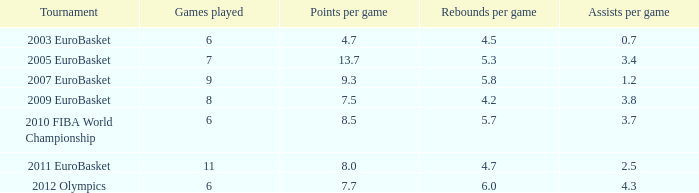How many assists per contest were there in the 2010 fiba world championship? 3.7. Would you be able to parse every entry in this table? {'header': ['Tournament', 'Games played', 'Points per game', 'Rebounds per game', 'Assists per game'], 'rows': [['2003 EuroBasket', '6', '4.7', '4.5', '0.7'], ['2005 EuroBasket', '7', '13.7', '5.3', '3.4'], ['2007 EuroBasket', '9', '9.3', '5.8', '1.2'], ['2009 EuroBasket', '8', '7.5', '4.2', '3.8'], ['2010 FIBA World Championship', '6', '8.5', '5.7', '3.7'], ['2011 EuroBasket', '11', '8.0', '4.7', '2.5'], ['2012 Olympics', '6', '7.7', '6.0', '4.3']]} 